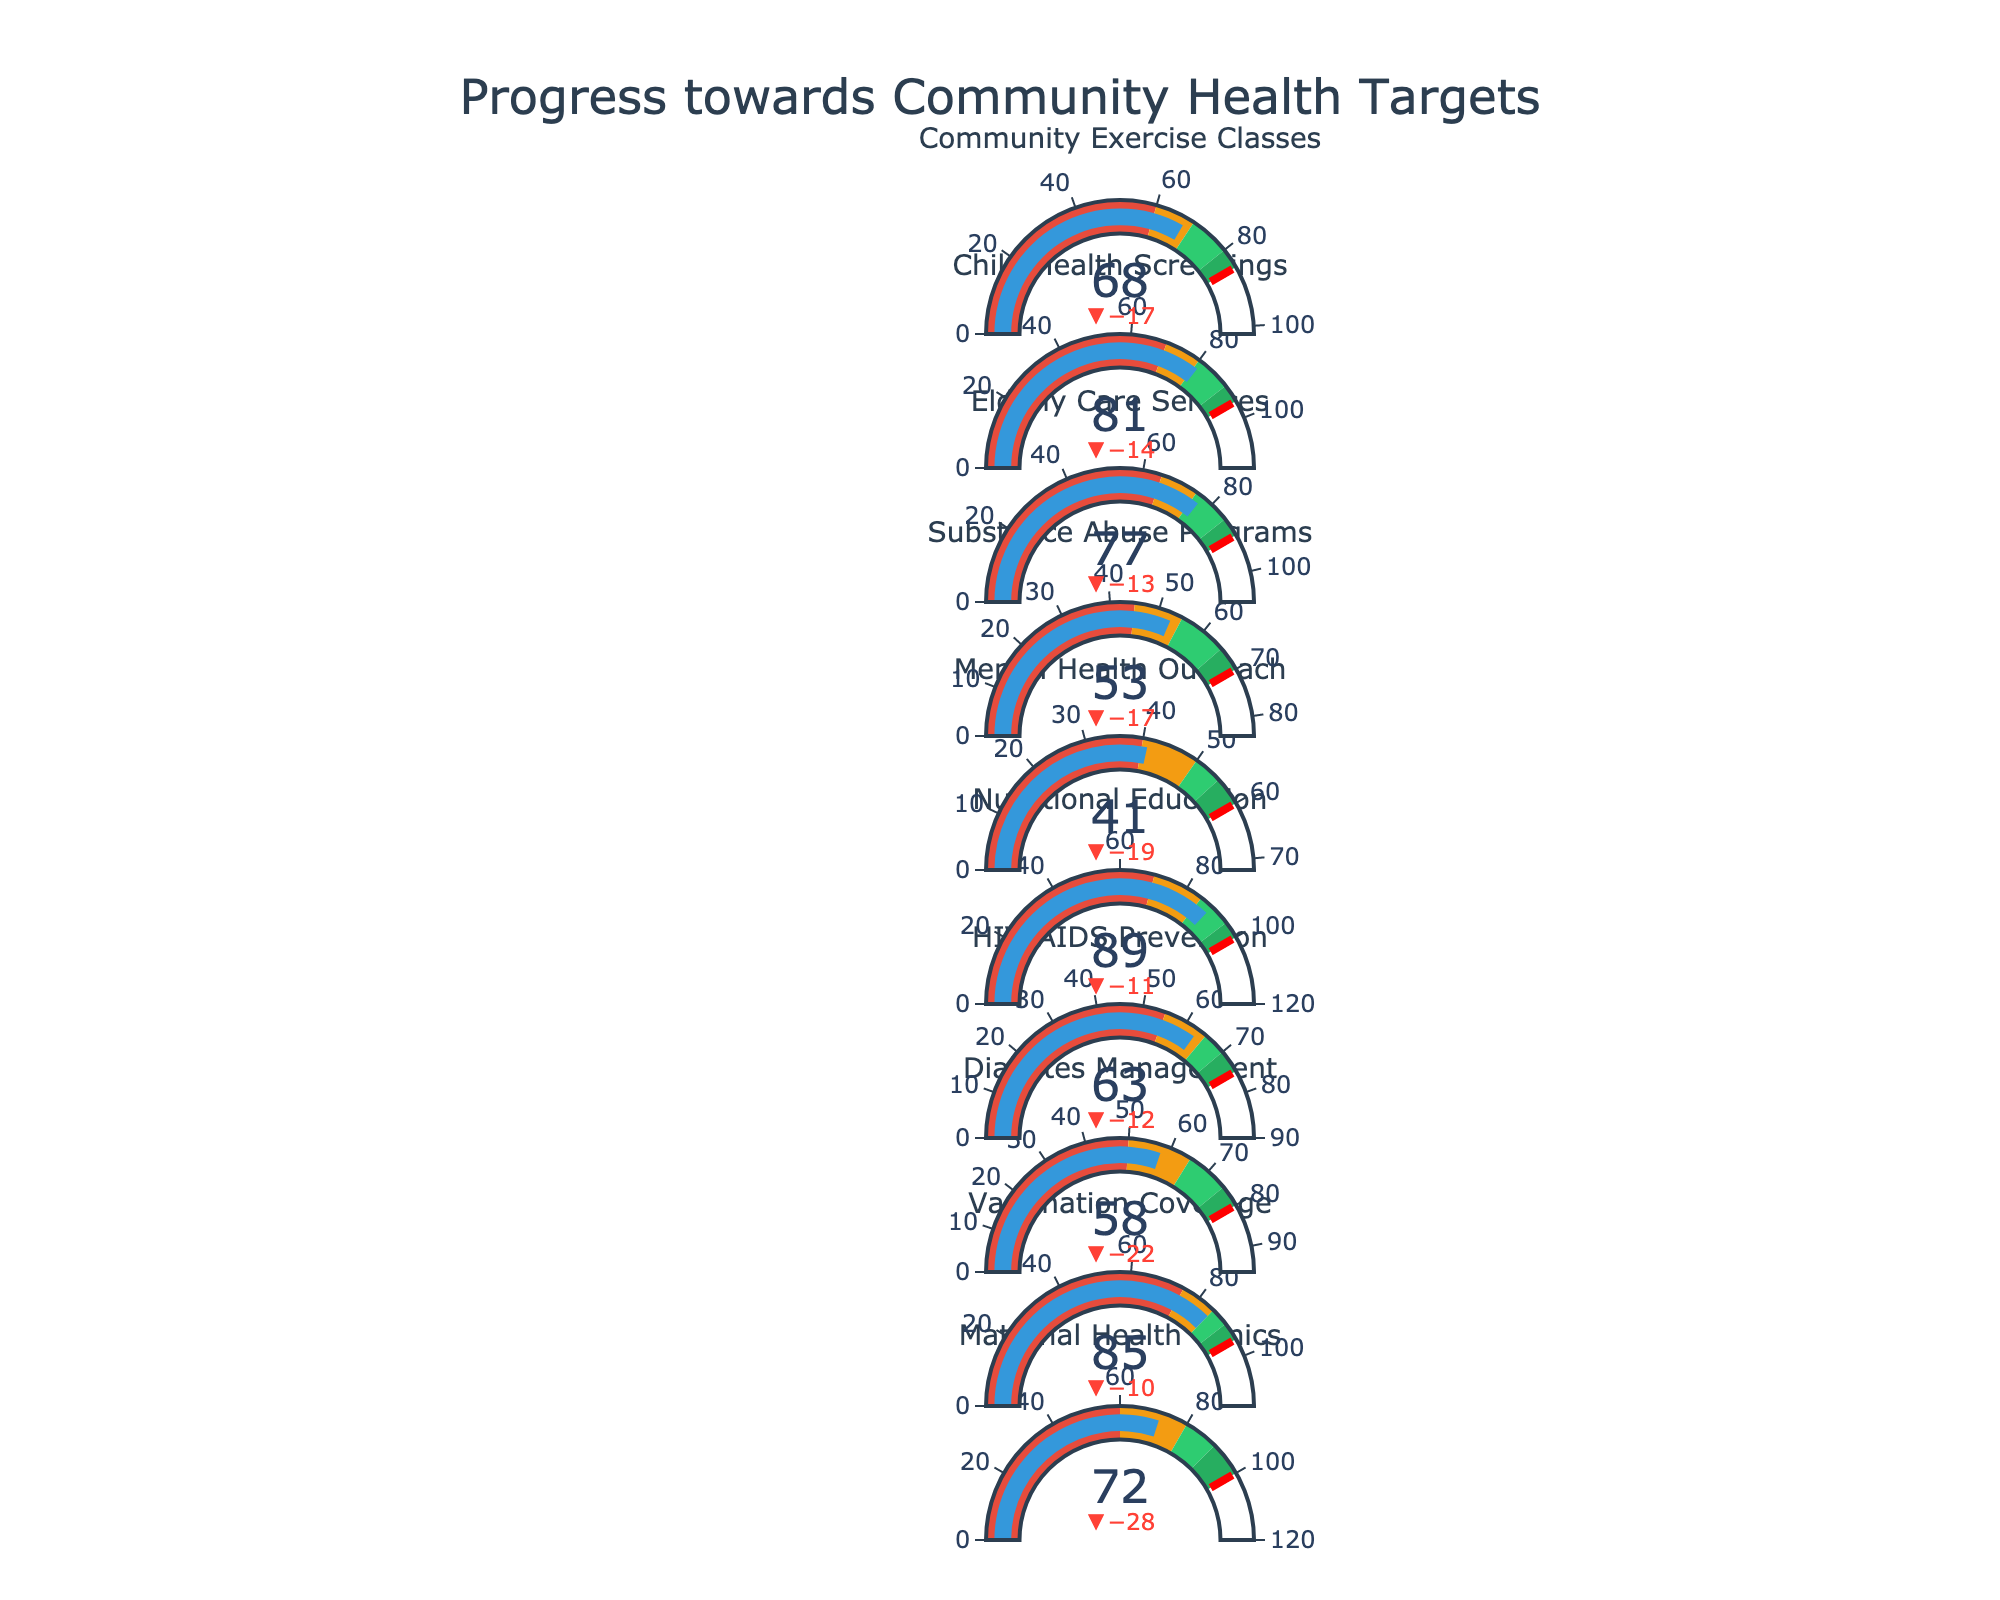How many health initiatives are tracked in this plot? Count the number of titles, each representing a different health initiative.
Answer: 10 What is the actual value for Maternal Health Clinics? Locate the indicator titled "Maternal Health Clinics" and read the actual value.
Answer: 72 Which initiative has the highest actual value? Compare the actual values of all initiatives and identify the highest one.
Answer: Nutritional Education How far is the Diabetes Management initiative from its target? Subtract the actual value (58) from the target value (80) for Diabetes Management.
Answer: 22 In which initiatives does the actual value exceed the target value? Compare the actual and target values for all initiatives and list those where the actual value is greater.
Answer: None What initiatives fall into the warning range based on their satisfaction level? Identify initiatives where the actual value is between the warning and satisfactory levels.
Answer: Diabetes Management, HIV/AIDS Prevention, Mental Health Outreach, Substance Abuse Programs, Community Exercise Classes Which initiative is performing the best relative to its satisfactory level? Calculate the difference between the actual and satisfactory levels for all initiatives and determine the one with the greatest positive difference.
Answer: Nutritional Education What color represents the satisfactory range for each initiative? Note the color used for the satisfactory range across all initiatives.
Answer: Yellow How many initiatives have actual values below their warning levels? Count the initiatives with actual values less than their warning levels.
Answer: None What is the difference between the target and good levels for Elderly Care Services? Subtract the good level (85) from the target level (90) for Elderly Care Services.
Answer: 5 